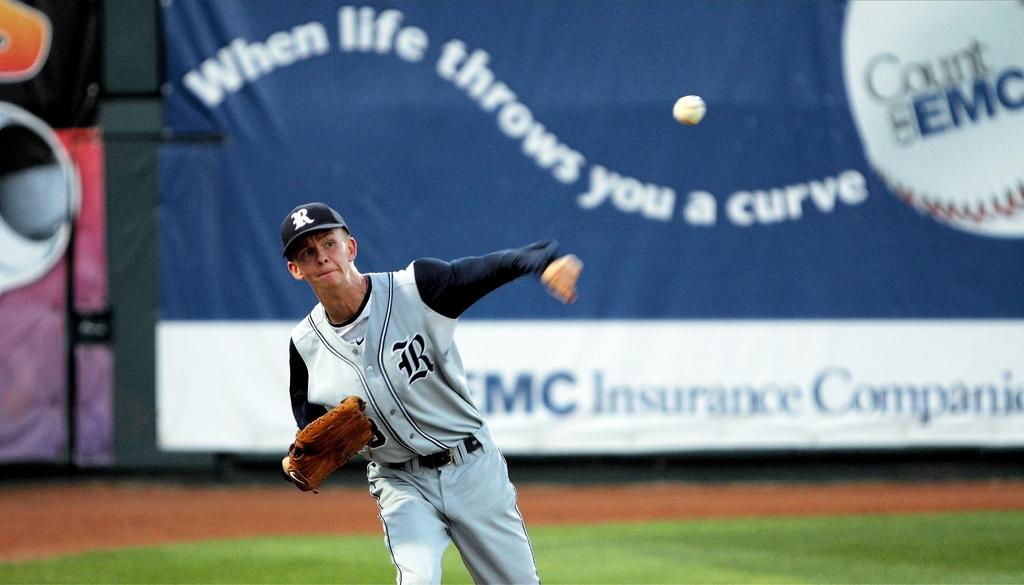What letter is on the baseball player's uniform?
Make the answer very short. R. What is the insurance company on the back board?
Ensure brevity in your answer.  Emc. 